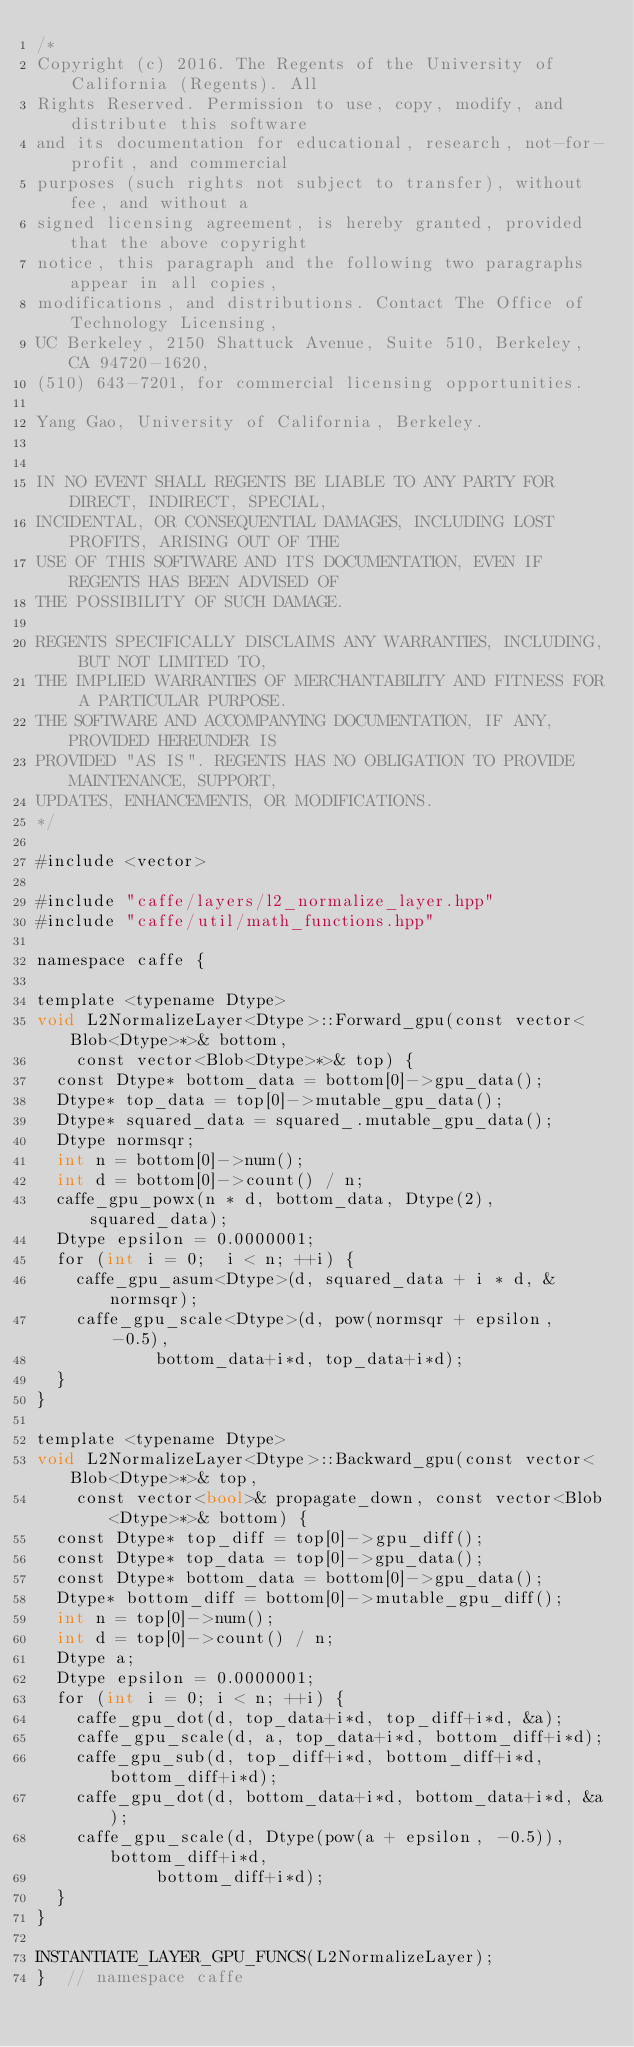<code> <loc_0><loc_0><loc_500><loc_500><_Cuda_>/*
Copyright (c) 2016. The Regents of the University of California (Regents). All
Rights Reserved. Permission to use, copy, modify, and distribute this software
and its documentation for educational, research, not-for-profit, and commercial
purposes (such rights not subject to transfer), without fee, and without a
signed licensing agreement, is hereby granted, provided that the above copyright
notice, this paragraph and the following two paragraphs appear in all copies,
modifications, and distributions. Contact The Office of Technology Licensing,
UC Berkeley, 2150 Shattuck Avenue, Suite 510, Berkeley, CA 94720-1620,
(510) 643-7201, for commercial licensing opportunities.

Yang Gao, University of California, Berkeley.


IN NO EVENT SHALL REGENTS BE LIABLE TO ANY PARTY FOR DIRECT, INDIRECT, SPECIAL,
INCIDENTAL, OR CONSEQUENTIAL DAMAGES, INCLUDING LOST PROFITS, ARISING OUT OF THE
USE OF THIS SOFTWARE AND ITS DOCUMENTATION, EVEN IF REGENTS HAS BEEN ADVISED OF
THE POSSIBILITY OF SUCH DAMAGE.

REGENTS SPECIFICALLY DISCLAIMS ANY WARRANTIES, INCLUDING, BUT NOT LIMITED TO,
THE IMPLIED WARRANTIES OF MERCHANTABILITY AND FITNESS FOR A PARTICULAR PURPOSE.
THE SOFTWARE AND ACCOMPANYING DOCUMENTATION, IF ANY, PROVIDED HEREUNDER IS
PROVIDED "AS IS". REGENTS HAS NO OBLIGATION TO PROVIDE MAINTENANCE, SUPPORT,
UPDATES, ENHANCEMENTS, OR MODIFICATIONS.
*/

#include <vector>

#include "caffe/layers/l2_normalize_layer.hpp"
#include "caffe/util/math_functions.hpp"

namespace caffe {

template <typename Dtype>
void L2NormalizeLayer<Dtype>::Forward_gpu(const vector<Blob<Dtype>*>& bottom,
    const vector<Blob<Dtype>*>& top) {
  const Dtype* bottom_data = bottom[0]->gpu_data();
  Dtype* top_data = top[0]->mutable_gpu_data();
  Dtype* squared_data = squared_.mutable_gpu_data();
  Dtype normsqr;
  int n = bottom[0]->num();
  int d = bottom[0]->count() / n;
  caffe_gpu_powx(n * d, bottom_data, Dtype(2), squared_data);
  Dtype epsilon = 0.0000001;
  for (int i = 0;  i < n; ++i) {
    caffe_gpu_asum<Dtype>(d, squared_data + i * d, &normsqr);
    caffe_gpu_scale<Dtype>(d, pow(normsqr + epsilon, -0.5),
            bottom_data+i*d, top_data+i*d);
  }
}

template <typename Dtype>
void L2NormalizeLayer<Dtype>::Backward_gpu(const vector<Blob<Dtype>*>& top,
    const vector<bool>& propagate_down, const vector<Blob<Dtype>*>& bottom) {
  const Dtype* top_diff = top[0]->gpu_diff();
  const Dtype* top_data = top[0]->gpu_data();
  const Dtype* bottom_data = bottom[0]->gpu_data();
  Dtype* bottom_diff = bottom[0]->mutable_gpu_diff();
  int n = top[0]->num();
  int d = top[0]->count() / n;
  Dtype a;
  Dtype epsilon = 0.0000001;
  for (int i = 0; i < n; ++i) {
    caffe_gpu_dot(d, top_data+i*d, top_diff+i*d, &a);
    caffe_gpu_scale(d, a, top_data+i*d, bottom_diff+i*d);
    caffe_gpu_sub(d, top_diff+i*d, bottom_diff+i*d, bottom_diff+i*d);
    caffe_gpu_dot(d, bottom_data+i*d, bottom_data+i*d, &a);
    caffe_gpu_scale(d, Dtype(pow(a + epsilon, -0.5)), bottom_diff+i*d,
            bottom_diff+i*d);
  }
}

INSTANTIATE_LAYER_GPU_FUNCS(L2NormalizeLayer);
}  // namespace caffe
</code> 